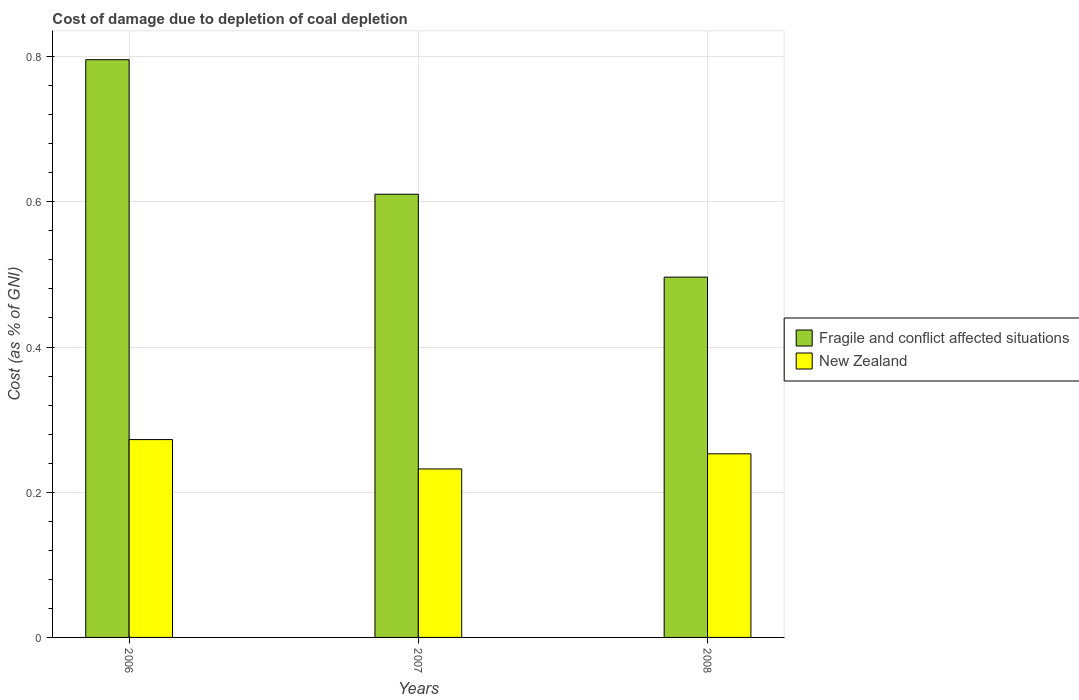Are the number of bars per tick equal to the number of legend labels?
Ensure brevity in your answer.  Yes. How many bars are there on the 2nd tick from the right?
Provide a short and direct response. 2. What is the label of the 3rd group of bars from the left?
Make the answer very short. 2008. In how many cases, is the number of bars for a given year not equal to the number of legend labels?
Ensure brevity in your answer.  0. What is the cost of damage caused due to coal depletion in New Zealand in 2006?
Offer a terse response. 0.27. Across all years, what is the maximum cost of damage caused due to coal depletion in Fragile and conflict affected situations?
Provide a short and direct response. 0.8. Across all years, what is the minimum cost of damage caused due to coal depletion in Fragile and conflict affected situations?
Provide a short and direct response. 0.5. In which year was the cost of damage caused due to coal depletion in Fragile and conflict affected situations maximum?
Provide a succinct answer. 2006. What is the total cost of damage caused due to coal depletion in Fragile and conflict affected situations in the graph?
Give a very brief answer. 1.9. What is the difference between the cost of damage caused due to coal depletion in Fragile and conflict affected situations in 2007 and that in 2008?
Make the answer very short. 0.11. What is the difference between the cost of damage caused due to coal depletion in Fragile and conflict affected situations in 2007 and the cost of damage caused due to coal depletion in New Zealand in 2006?
Give a very brief answer. 0.34. What is the average cost of damage caused due to coal depletion in Fragile and conflict affected situations per year?
Your answer should be compact. 0.63. In the year 2006, what is the difference between the cost of damage caused due to coal depletion in Fragile and conflict affected situations and cost of damage caused due to coal depletion in New Zealand?
Give a very brief answer. 0.52. In how many years, is the cost of damage caused due to coal depletion in Fragile and conflict affected situations greater than 0.68 %?
Ensure brevity in your answer.  1. What is the ratio of the cost of damage caused due to coal depletion in Fragile and conflict affected situations in 2006 to that in 2007?
Provide a short and direct response. 1.3. Is the cost of damage caused due to coal depletion in New Zealand in 2006 less than that in 2007?
Your answer should be compact. No. What is the difference between the highest and the second highest cost of damage caused due to coal depletion in New Zealand?
Keep it short and to the point. 0.02. What is the difference between the highest and the lowest cost of damage caused due to coal depletion in Fragile and conflict affected situations?
Keep it short and to the point. 0.3. What does the 2nd bar from the left in 2006 represents?
Ensure brevity in your answer.  New Zealand. What does the 2nd bar from the right in 2006 represents?
Offer a terse response. Fragile and conflict affected situations. What is the difference between two consecutive major ticks on the Y-axis?
Ensure brevity in your answer.  0.2. Does the graph contain grids?
Offer a terse response. Yes. Where does the legend appear in the graph?
Your answer should be compact. Center right. What is the title of the graph?
Your response must be concise. Cost of damage due to depletion of coal depletion. What is the label or title of the X-axis?
Give a very brief answer. Years. What is the label or title of the Y-axis?
Ensure brevity in your answer.  Cost (as % of GNI). What is the Cost (as % of GNI) of Fragile and conflict affected situations in 2006?
Provide a short and direct response. 0.8. What is the Cost (as % of GNI) in New Zealand in 2006?
Provide a succinct answer. 0.27. What is the Cost (as % of GNI) of Fragile and conflict affected situations in 2007?
Your answer should be very brief. 0.61. What is the Cost (as % of GNI) of New Zealand in 2007?
Offer a terse response. 0.23. What is the Cost (as % of GNI) in Fragile and conflict affected situations in 2008?
Your answer should be very brief. 0.5. What is the Cost (as % of GNI) in New Zealand in 2008?
Provide a succinct answer. 0.25. Across all years, what is the maximum Cost (as % of GNI) in Fragile and conflict affected situations?
Provide a short and direct response. 0.8. Across all years, what is the maximum Cost (as % of GNI) of New Zealand?
Keep it short and to the point. 0.27. Across all years, what is the minimum Cost (as % of GNI) in Fragile and conflict affected situations?
Give a very brief answer. 0.5. Across all years, what is the minimum Cost (as % of GNI) in New Zealand?
Your answer should be compact. 0.23. What is the total Cost (as % of GNI) in Fragile and conflict affected situations in the graph?
Ensure brevity in your answer.  1.9. What is the total Cost (as % of GNI) in New Zealand in the graph?
Keep it short and to the point. 0.76. What is the difference between the Cost (as % of GNI) of Fragile and conflict affected situations in 2006 and that in 2007?
Your answer should be compact. 0.19. What is the difference between the Cost (as % of GNI) in New Zealand in 2006 and that in 2007?
Give a very brief answer. 0.04. What is the difference between the Cost (as % of GNI) in Fragile and conflict affected situations in 2006 and that in 2008?
Keep it short and to the point. 0.3. What is the difference between the Cost (as % of GNI) in New Zealand in 2006 and that in 2008?
Your answer should be very brief. 0.02. What is the difference between the Cost (as % of GNI) of Fragile and conflict affected situations in 2007 and that in 2008?
Keep it short and to the point. 0.11. What is the difference between the Cost (as % of GNI) of New Zealand in 2007 and that in 2008?
Make the answer very short. -0.02. What is the difference between the Cost (as % of GNI) of Fragile and conflict affected situations in 2006 and the Cost (as % of GNI) of New Zealand in 2007?
Your answer should be compact. 0.56. What is the difference between the Cost (as % of GNI) in Fragile and conflict affected situations in 2006 and the Cost (as % of GNI) in New Zealand in 2008?
Offer a terse response. 0.54. What is the difference between the Cost (as % of GNI) of Fragile and conflict affected situations in 2007 and the Cost (as % of GNI) of New Zealand in 2008?
Provide a short and direct response. 0.36. What is the average Cost (as % of GNI) of Fragile and conflict affected situations per year?
Make the answer very short. 0.63. What is the average Cost (as % of GNI) of New Zealand per year?
Keep it short and to the point. 0.25. In the year 2006, what is the difference between the Cost (as % of GNI) of Fragile and conflict affected situations and Cost (as % of GNI) of New Zealand?
Provide a succinct answer. 0.52. In the year 2007, what is the difference between the Cost (as % of GNI) of Fragile and conflict affected situations and Cost (as % of GNI) of New Zealand?
Offer a terse response. 0.38. In the year 2008, what is the difference between the Cost (as % of GNI) of Fragile and conflict affected situations and Cost (as % of GNI) of New Zealand?
Make the answer very short. 0.24. What is the ratio of the Cost (as % of GNI) of Fragile and conflict affected situations in 2006 to that in 2007?
Give a very brief answer. 1.3. What is the ratio of the Cost (as % of GNI) of New Zealand in 2006 to that in 2007?
Ensure brevity in your answer.  1.17. What is the ratio of the Cost (as % of GNI) of Fragile and conflict affected situations in 2006 to that in 2008?
Your answer should be very brief. 1.6. What is the ratio of the Cost (as % of GNI) in New Zealand in 2006 to that in 2008?
Offer a terse response. 1.08. What is the ratio of the Cost (as % of GNI) in Fragile and conflict affected situations in 2007 to that in 2008?
Keep it short and to the point. 1.23. What is the ratio of the Cost (as % of GNI) in New Zealand in 2007 to that in 2008?
Provide a succinct answer. 0.92. What is the difference between the highest and the second highest Cost (as % of GNI) in Fragile and conflict affected situations?
Make the answer very short. 0.19. What is the difference between the highest and the second highest Cost (as % of GNI) of New Zealand?
Provide a short and direct response. 0.02. What is the difference between the highest and the lowest Cost (as % of GNI) of Fragile and conflict affected situations?
Offer a terse response. 0.3. What is the difference between the highest and the lowest Cost (as % of GNI) in New Zealand?
Your answer should be compact. 0.04. 